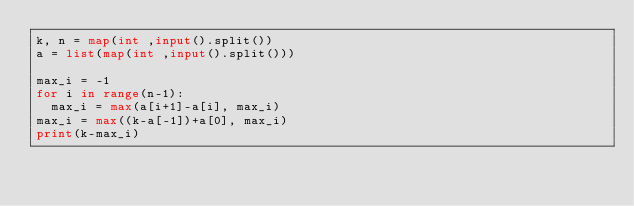Convert code to text. <code><loc_0><loc_0><loc_500><loc_500><_Python_>k, n = map(int ,input().split())
a = list(map(int ,input().split()))

max_i = -1
for i in range(n-1):
  max_i = max(a[i+1]-a[i], max_i)
max_i = max((k-a[-1])+a[0], max_i)
print(k-max_i)</code> 